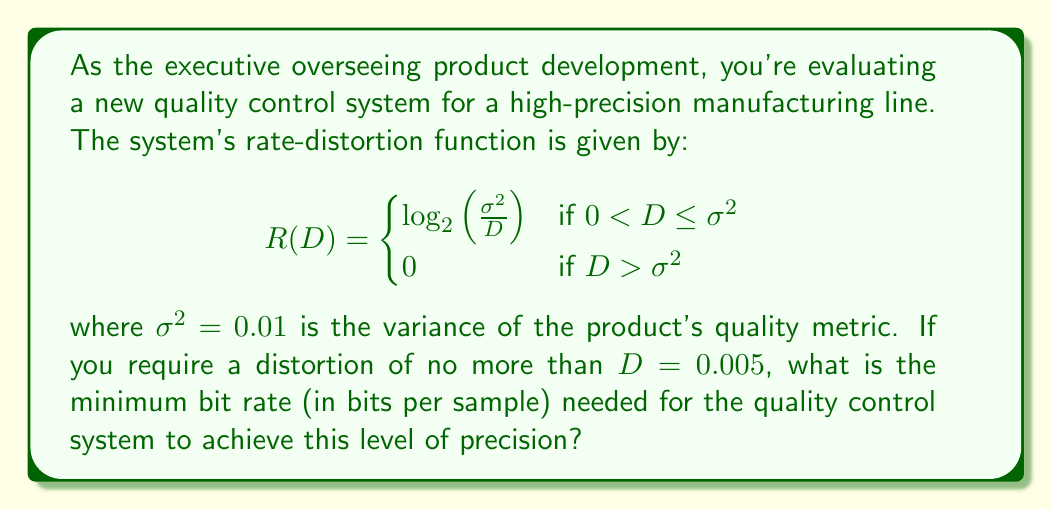Show me your answer to this math problem. To solve this problem, we need to use the rate-distortion function provided and plug in the given values. Let's follow these steps:

1. We're given that $\sigma^2 = 0.01$ and $D = 0.005$.

2. First, we need to check which case of the rate-distortion function applies. We know that:
   $0 < D \leq \sigma^2$
   $0 < 0.005 \leq 0.01$
   This is true, so we use the first case of the function.

3. Now we can apply the formula:
   $$R(D) = \log_2\left(\frac{\sigma^2}{D}\right)$$

4. Substituting the values:
   $$R(0.005) = \log_2\left(\frac{0.01}{0.005}\right)$$

5. Simplify inside the logarithm:
   $$R(0.005) = \log_2(2)$$

6. The logarithm base 2 of 2 is 1, so:
   $$R(0.005) = 1$$

Therefore, the minimum bit rate needed is 1 bit per sample.
Answer: 1 bit per sample 